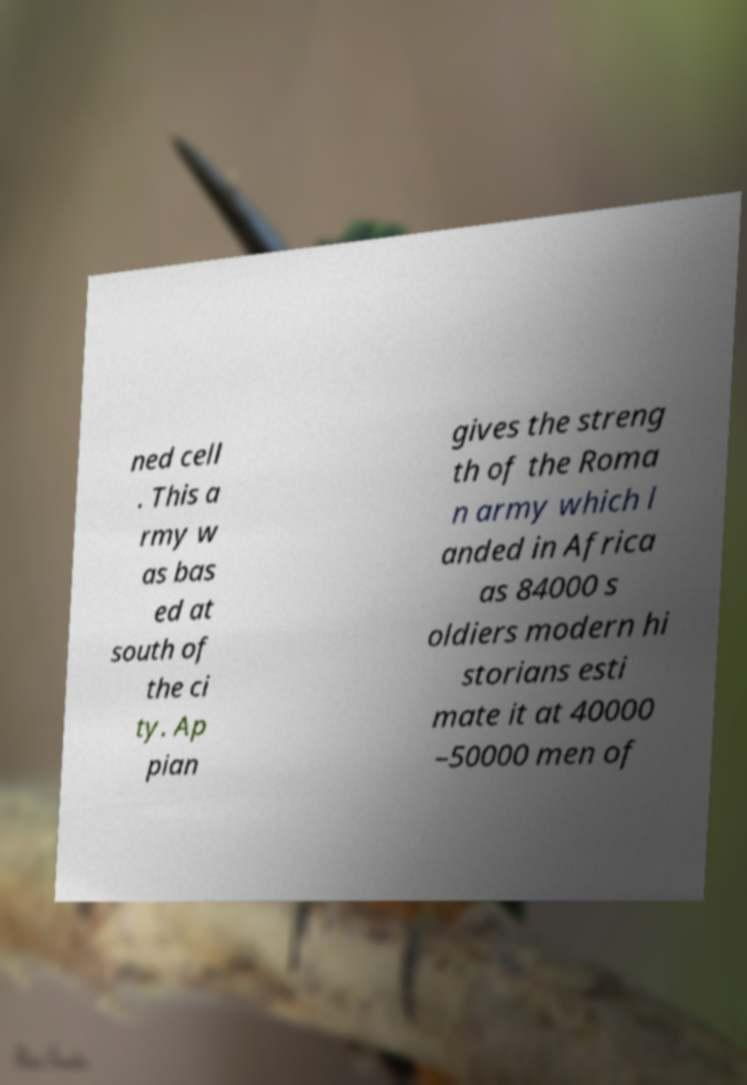Could you extract and type out the text from this image? ned cell . This a rmy w as bas ed at south of the ci ty. Ap pian gives the streng th of the Roma n army which l anded in Africa as 84000 s oldiers modern hi storians esti mate it at 40000 –50000 men of 